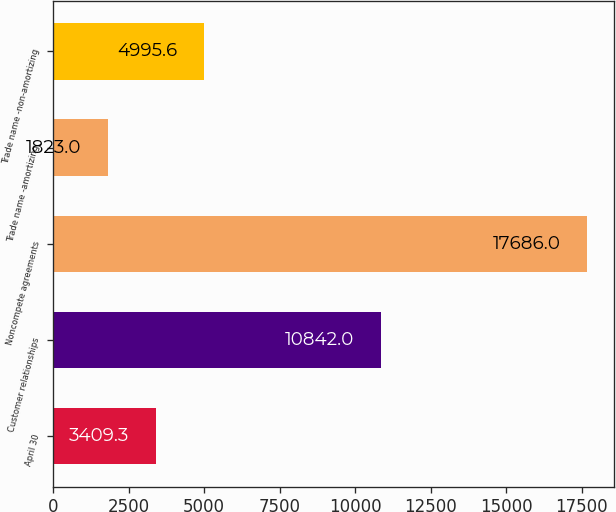Convert chart to OTSL. <chart><loc_0><loc_0><loc_500><loc_500><bar_chart><fcel>April 30<fcel>Customer relationships<fcel>Noncompete agreements<fcel>Trade name -amortizing<fcel>Trade name -non-amortizing<nl><fcel>3409.3<fcel>10842<fcel>17686<fcel>1823<fcel>4995.6<nl></chart> 